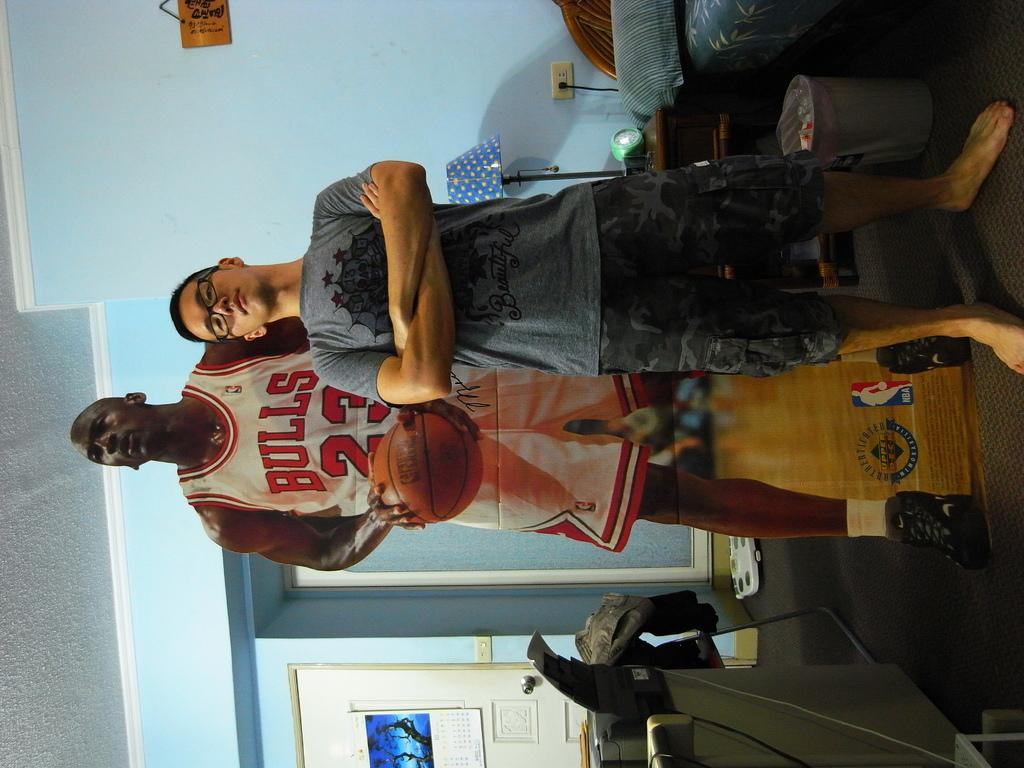<image>
Offer a succinct explanation of the picture presented. Man standing next to a poster of a basketball player wearing number 23. 